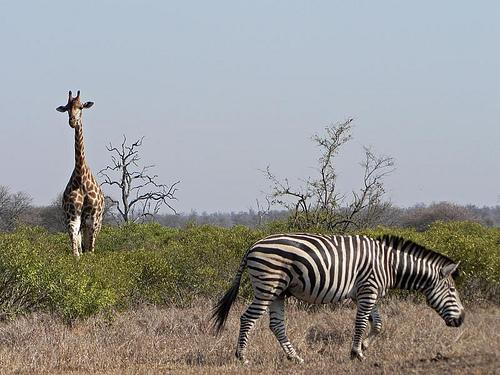Would a lion eat these animals in this picture?
Quick response, please. Yes. What Color is the giraffe's nose?
Quick response, please. Brown. Where could this be?
Write a very short answer. Africa. How is the back half of the animal's pattern different than the front half?
Short answer required. Horizontal stripes. How many types of animal are in the picture?
Give a very brief answer. 2. 